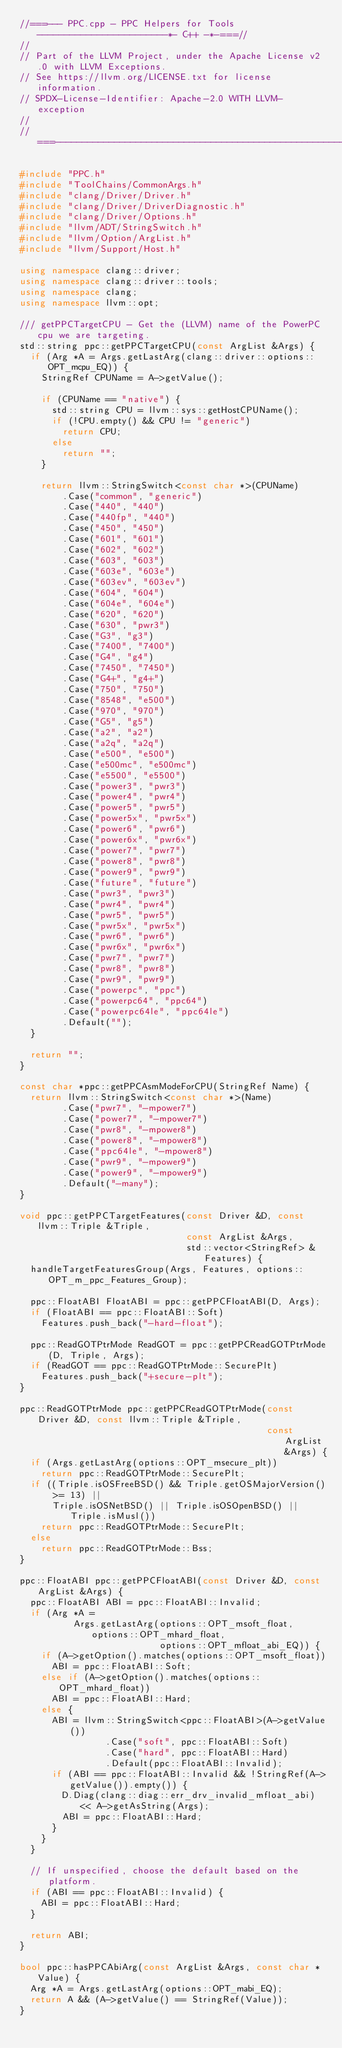<code> <loc_0><loc_0><loc_500><loc_500><_C++_>//===--- PPC.cpp - PPC Helpers for Tools ------------------------*- C++ -*-===//
//
// Part of the LLVM Project, under the Apache License v2.0 with LLVM Exceptions.
// See https://llvm.org/LICENSE.txt for license information.
// SPDX-License-Identifier: Apache-2.0 WITH LLVM-exception
//
//===----------------------------------------------------------------------===//

#include "PPC.h"
#include "ToolChains/CommonArgs.h"
#include "clang/Driver/Driver.h"
#include "clang/Driver/DriverDiagnostic.h"
#include "clang/Driver/Options.h"
#include "llvm/ADT/StringSwitch.h"
#include "llvm/Option/ArgList.h"
#include "llvm/Support/Host.h"

using namespace clang::driver;
using namespace clang::driver::tools;
using namespace clang;
using namespace llvm::opt;

/// getPPCTargetCPU - Get the (LLVM) name of the PowerPC cpu we are targeting.
std::string ppc::getPPCTargetCPU(const ArgList &Args) {
  if (Arg *A = Args.getLastArg(clang::driver::options::OPT_mcpu_EQ)) {
    StringRef CPUName = A->getValue();

    if (CPUName == "native") {
      std::string CPU = llvm::sys::getHostCPUName();
      if (!CPU.empty() && CPU != "generic")
        return CPU;
      else
        return "";
    }

    return llvm::StringSwitch<const char *>(CPUName)
        .Case("common", "generic")
        .Case("440", "440")
        .Case("440fp", "440")
        .Case("450", "450")
        .Case("601", "601")
        .Case("602", "602")
        .Case("603", "603")
        .Case("603e", "603e")
        .Case("603ev", "603ev")
        .Case("604", "604")
        .Case("604e", "604e")
        .Case("620", "620")
        .Case("630", "pwr3")
        .Case("G3", "g3")
        .Case("7400", "7400")
        .Case("G4", "g4")
        .Case("7450", "7450")
        .Case("G4+", "g4+")
        .Case("750", "750")
        .Case("8548", "e500")
        .Case("970", "970")
        .Case("G5", "g5")
        .Case("a2", "a2")
        .Case("a2q", "a2q")
        .Case("e500", "e500")
        .Case("e500mc", "e500mc")
        .Case("e5500", "e5500")
        .Case("power3", "pwr3")
        .Case("power4", "pwr4")
        .Case("power5", "pwr5")
        .Case("power5x", "pwr5x")
        .Case("power6", "pwr6")
        .Case("power6x", "pwr6x")
        .Case("power7", "pwr7")
        .Case("power8", "pwr8")
        .Case("power9", "pwr9")
        .Case("future", "future")
        .Case("pwr3", "pwr3")
        .Case("pwr4", "pwr4")
        .Case("pwr5", "pwr5")
        .Case("pwr5x", "pwr5x")
        .Case("pwr6", "pwr6")
        .Case("pwr6x", "pwr6x")
        .Case("pwr7", "pwr7")
        .Case("pwr8", "pwr8")
        .Case("pwr9", "pwr9")
        .Case("powerpc", "ppc")
        .Case("powerpc64", "ppc64")
        .Case("powerpc64le", "ppc64le")
        .Default("");
  }

  return "";
}

const char *ppc::getPPCAsmModeForCPU(StringRef Name) {
  return llvm::StringSwitch<const char *>(Name)
        .Case("pwr7", "-mpower7")
        .Case("power7", "-mpower7")
        .Case("pwr8", "-mpower8")
        .Case("power8", "-mpower8")
        .Case("ppc64le", "-mpower8")
        .Case("pwr9", "-mpower9")
        .Case("power9", "-mpower9")
        .Default("-many");
}

void ppc::getPPCTargetFeatures(const Driver &D, const llvm::Triple &Triple,
                               const ArgList &Args,
                               std::vector<StringRef> &Features) {
  handleTargetFeaturesGroup(Args, Features, options::OPT_m_ppc_Features_Group);

  ppc::FloatABI FloatABI = ppc::getPPCFloatABI(D, Args);
  if (FloatABI == ppc::FloatABI::Soft)
    Features.push_back("-hard-float");

  ppc::ReadGOTPtrMode ReadGOT = ppc::getPPCReadGOTPtrMode(D, Triple, Args);
  if (ReadGOT == ppc::ReadGOTPtrMode::SecurePlt)
    Features.push_back("+secure-plt");
}

ppc::ReadGOTPtrMode ppc::getPPCReadGOTPtrMode(const Driver &D, const llvm::Triple &Triple,
                                              const ArgList &Args) {
  if (Args.getLastArg(options::OPT_msecure_plt))
    return ppc::ReadGOTPtrMode::SecurePlt;
  if ((Triple.isOSFreeBSD() && Triple.getOSMajorVersion() >= 13) ||
      Triple.isOSNetBSD() || Triple.isOSOpenBSD() || Triple.isMusl())
    return ppc::ReadGOTPtrMode::SecurePlt;
  else
    return ppc::ReadGOTPtrMode::Bss;
}

ppc::FloatABI ppc::getPPCFloatABI(const Driver &D, const ArgList &Args) {
  ppc::FloatABI ABI = ppc::FloatABI::Invalid;
  if (Arg *A =
          Args.getLastArg(options::OPT_msoft_float, options::OPT_mhard_float,
                          options::OPT_mfloat_abi_EQ)) {
    if (A->getOption().matches(options::OPT_msoft_float))
      ABI = ppc::FloatABI::Soft;
    else if (A->getOption().matches(options::OPT_mhard_float))
      ABI = ppc::FloatABI::Hard;
    else {
      ABI = llvm::StringSwitch<ppc::FloatABI>(A->getValue())
                .Case("soft", ppc::FloatABI::Soft)
                .Case("hard", ppc::FloatABI::Hard)
                .Default(ppc::FloatABI::Invalid);
      if (ABI == ppc::FloatABI::Invalid && !StringRef(A->getValue()).empty()) {
        D.Diag(clang::diag::err_drv_invalid_mfloat_abi) << A->getAsString(Args);
        ABI = ppc::FloatABI::Hard;
      }
    }
  }

  // If unspecified, choose the default based on the platform.
  if (ABI == ppc::FloatABI::Invalid) {
    ABI = ppc::FloatABI::Hard;
  }

  return ABI;
}

bool ppc::hasPPCAbiArg(const ArgList &Args, const char *Value) {
  Arg *A = Args.getLastArg(options::OPT_mabi_EQ);
  return A && (A->getValue() == StringRef(Value));
}
</code> 